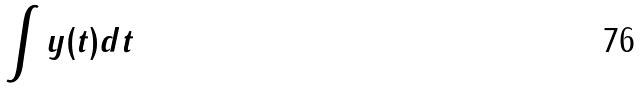Convert formula to latex. <formula><loc_0><loc_0><loc_500><loc_500>\int y ( t ) d t</formula> 